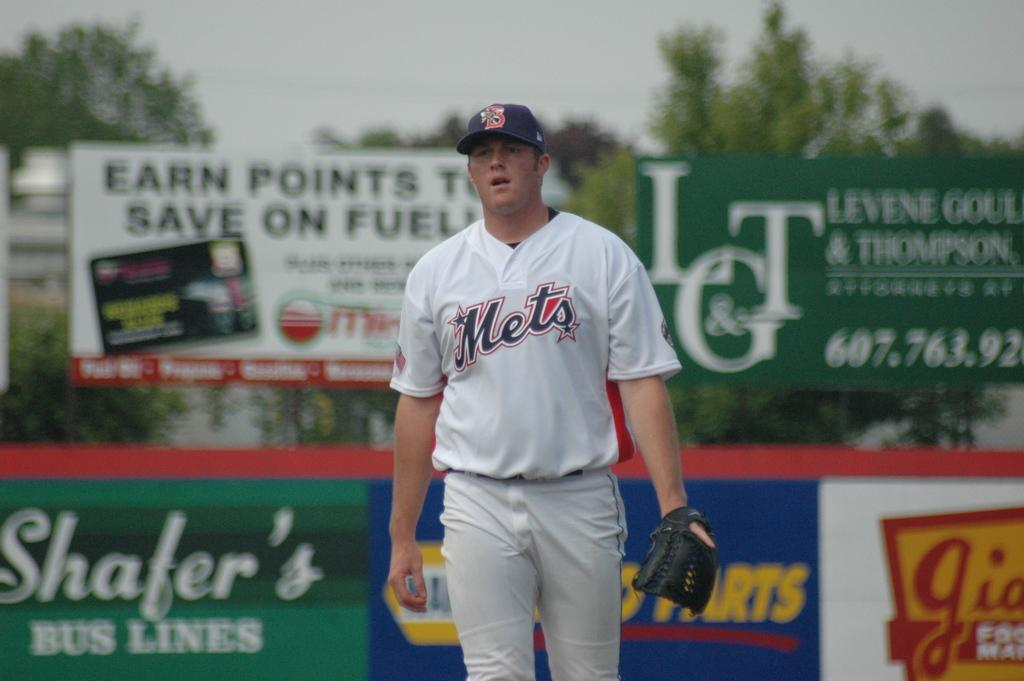Provide a one-sentence caption for the provided image. A man in a Mets shirt and cap standing and looking. 